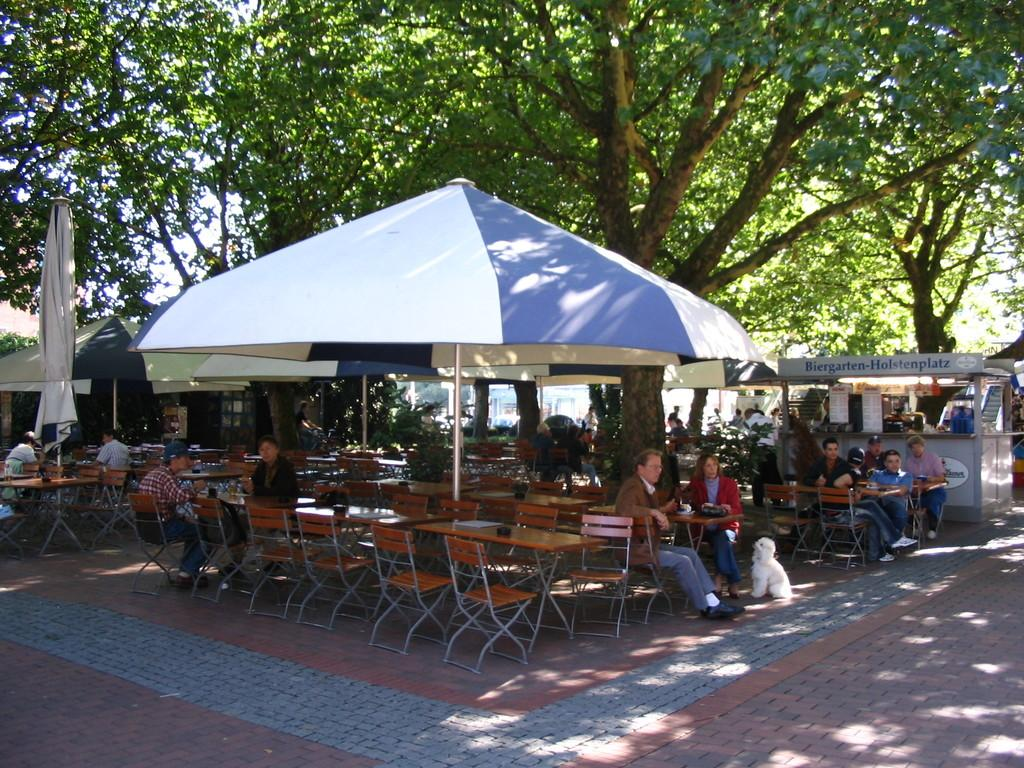What type of vegetation can be seen in the image? There are trees in the image. What object is present for protection from the sun or rain? There is an umbrella in the image. What type of furniture is visible in the image? There are tables and chairs in the image. Are there any people present in the image? Yes, there are people present in the image. Can you tell me how many mice are sitting on the chairs in the image? There are no mice present in the image; only people are visible. Who is the manager of the people in the image? There is no indication of a manager or any hierarchy among the people in the image. 